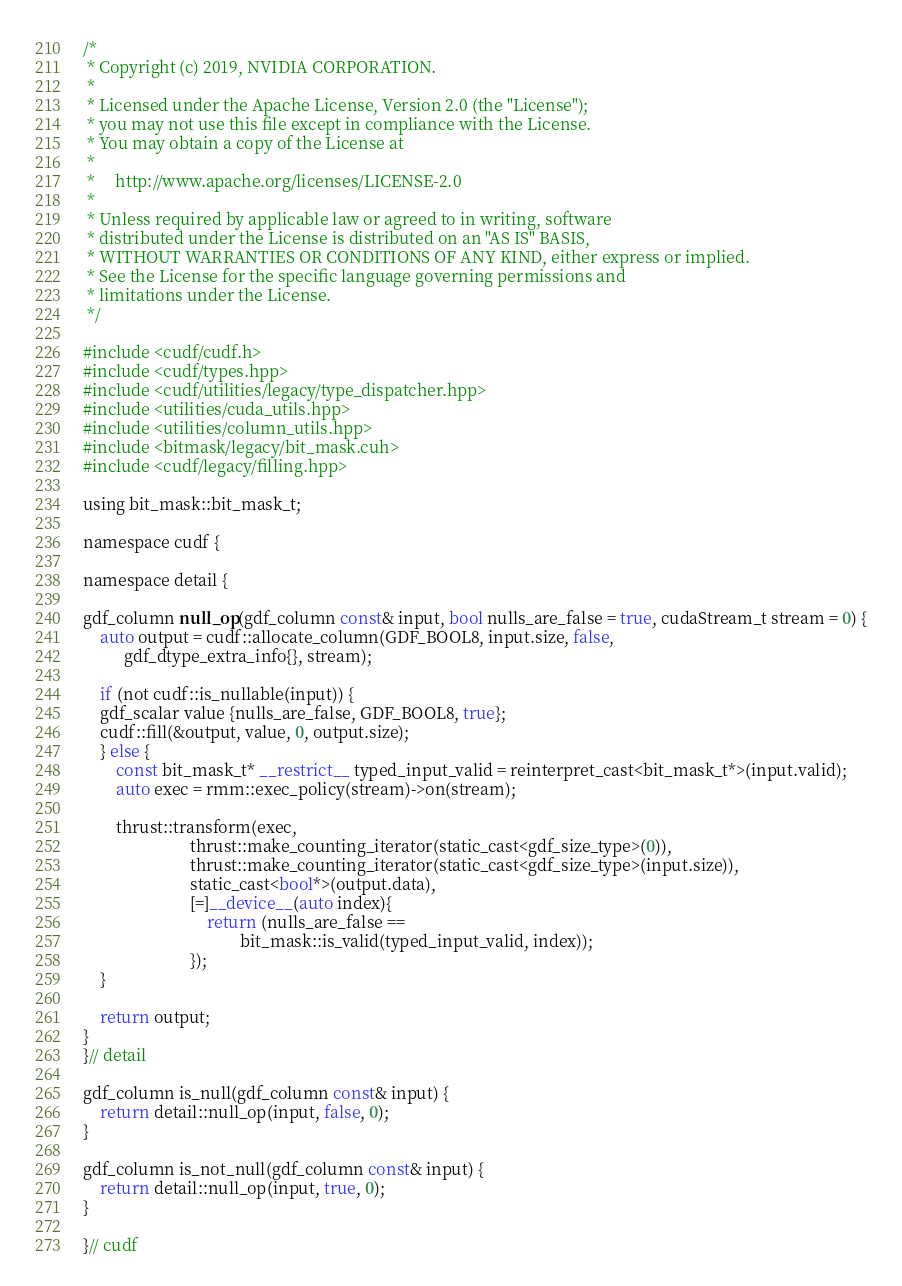<code> <loc_0><loc_0><loc_500><loc_500><_Cuda_>/*
 * Copyright (c) 2019, NVIDIA CORPORATION.
 *
 * Licensed under the Apache License, Version 2.0 (the "License");
 * you may not use this file except in compliance with the License.
 * You may obtain a copy of the License at
 *
 *     http://www.apache.org/licenses/LICENSE-2.0
 *
 * Unless required by applicable law or agreed to in writing, software
 * distributed under the License is distributed on an "AS IS" BASIS,
 * WITHOUT WARRANTIES OR CONDITIONS OF ANY KIND, either express or implied.
 * See the License for the specific language governing permissions and
 * limitations under the License.
 */

#include <cudf/cudf.h>
#include <cudf/types.hpp>
#include <cudf/utilities/legacy/type_dispatcher.hpp>
#include <utilities/cuda_utils.hpp>
#include <utilities/column_utils.hpp>
#include <bitmask/legacy/bit_mask.cuh>
#include <cudf/legacy/filling.hpp>

using bit_mask::bit_mask_t;

namespace cudf {

namespace detail {

gdf_column null_op(gdf_column const& input, bool nulls_are_false = true, cudaStream_t stream = 0) {
    auto output = cudf::allocate_column(GDF_BOOL8, input.size, false, 
		  gdf_dtype_extra_info{}, stream);

    if (not cudf::is_nullable(input)) {
	gdf_scalar value {nulls_are_false, GDF_BOOL8, true}; 
	cudf::fill(&output, value, 0, output.size);
    } else {
        const bit_mask_t* __restrict__ typed_input_valid = reinterpret_cast<bit_mask_t*>(input.valid);
        auto exec = rmm::exec_policy(stream)->on(stream);

        thrust::transform(exec,
                          thrust::make_counting_iterator(static_cast<gdf_size_type>(0)),
                          thrust::make_counting_iterator(static_cast<gdf_size_type>(input.size)),
                          static_cast<bool*>(output.data),
                          [=]__device__(auto index){
                              return (nulls_are_false ==
                                      bit_mask::is_valid(typed_input_valid, index));
                          });
    }

    return output;
}
}// detail

gdf_column is_null(gdf_column const& input) {
    return detail::null_op(input, false, 0);
}

gdf_column is_not_null(gdf_column const& input) {
    return detail::null_op(input, true, 0);
}

}// cudf
</code> 